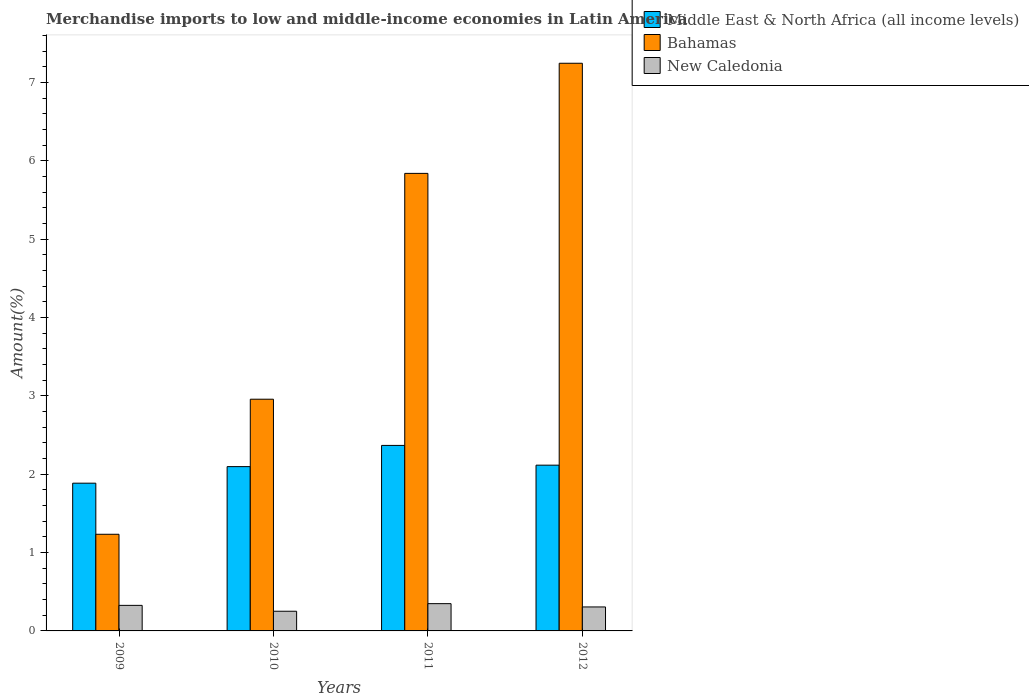How many different coloured bars are there?
Offer a very short reply. 3. Are the number of bars on each tick of the X-axis equal?
Your answer should be very brief. Yes. How many bars are there on the 3rd tick from the right?
Ensure brevity in your answer.  3. What is the percentage of amount earned from merchandise imports in Bahamas in 2012?
Keep it short and to the point. 7.25. Across all years, what is the maximum percentage of amount earned from merchandise imports in New Caledonia?
Offer a terse response. 0.35. Across all years, what is the minimum percentage of amount earned from merchandise imports in New Caledonia?
Your response must be concise. 0.25. What is the total percentage of amount earned from merchandise imports in Bahamas in the graph?
Your response must be concise. 17.28. What is the difference between the percentage of amount earned from merchandise imports in New Caledonia in 2011 and that in 2012?
Keep it short and to the point. 0.04. What is the difference between the percentage of amount earned from merchandise imports in Bahamas in 2011 and the percentage of amount earned from merchandise imports in New Caledonia in 2010?
Your response must be concise. 5.59. What is the average percentage of amount earned from merchandise imports in New Caledonia per year?
Give a very brief answer. 0.31. In the year 2012, what is the difference between the percentage of amount earned from merchandise imports in Bahamas and percentage of amount earned from merchandise imports in New Caledonia?
Offer a very short reply. 6.94. In how many years, is the percentage of amount earned from merchandise imports in Middle East & North Africa (all income levels) greater than 0.6000000000000001 %?
Provide a succinct answer. 4. What is the ratio of the percentage of amount earned from merchandise imports in New Caledonia in 2009 to that in 2012?
Offer a very short reply. 1.07. Is the difference between the percentage of amount earned from merchandise imports in Bahamas in 2009 and 2011 greater than the difference between the percentage of amount earned from merchandise imports in New Caledonia in 2009 and 2011?
Your response must be concise. No. What is the difference between the highest and the second highest percentage of amount earned from merchandise imports in New Caledonia?
Give a very brief answer. 0.02. What is the difference between the highest and the lowest percentage of amount earned from merchandise imports in New Caledonia?
Provide a short and direct response. 0.1. In how many years, is the percentage of amount earned from merchandise imports in Middle East & North Africa (all income levels) greater than the average percentage of amount earned from merchandise imports in Middle East & North Africa (all income levels) taken over all years?
Make the answer very short. 1. Is the sum of the percentage of amount earned from merchandise imports in New Caledonia in 2011 and 2012 greater than the maximum percentage of amount earned from merchandise imports in Bahamas across all years?
Give a very brief answer. No. What does the 1st bar from the left in 2012 represents?
Provide a succinct answer. Middle East & North Africa (all income levels). What does the 1st bar from the right in 2011 represents?
Your answer should be compact. New Caledonia. Is it the case that in every year, the sum of the percentage of amount earned from merchandise imports in Middle East & North Africa (all income levels) and percentage of amount earned from merchandise imports in New Caledonia is greater than the percentage of amount earned from merchandise imports in Bahamas?
Provide a succinct answer. No. Are all the bars in the graph horizontal?
Provide a succinct answer. No. Are the values on the major ticks of Y-axis written in scientific E-notation?
Provide a succinct answer. No. Does the graph contain any zero values?
Offer a terse response. No. Does the graph contain grids?
Ensure brevity in your answer.  No. Where does the legend appear in the graph?
Offer a very short reply. Top right. What is the title of the graph?
Provide a short and direct response. Merchandise imports to low and middle-income economies in Latin America. What is the label or title of the Y-axis?
Ensure brevity in your answer.  Amount(%). What is the Amount(%) in Middle East & North Africa (all income levels) in 2009?
Provide a short and direct response. 1.89. What is the Amount(%) of Bahamas in 2009?
Keep it short and to the point. 1.23. What is the Amount(%) of New Caledonia in 2009?
Offer a very short reply. 0.33. What is the Amount(%) of Middle East & North Africa (all income levels) in 2010?
Offer a terse response. 2.1. What is the Amount(%) of Bahamas in 2010?
Your answer should be very brief. 2.96. What is the Amount(%) in New Caledonia in 2010?
Offer a terse response. 0.25. What is the Amount(%) in Middle East & North Africa (all income levels) in 2011?
Offer a terse response. 2.37. What is the Amount(%) in Bahamas in 2011?
Offer a terse response. 5.84. What is the Amount(%) of New Caledonia in 2011?
Offer a very short reply. 0.35. What is the Amount(%) of Middle East & North Africa (all income levels) in 2012?
Offer a terse response. 2.12. What is the Amount(%) in Bahamas in 2012?
Make the answer very short. 7.25. What is the Amount(%) in New Caledonia in 2012?
Give a very brief answer. 0.31. Across all years, what is the maximum Amount(%) in Middle East & North Africa (all income levels)?
Your response must be concise. 2.37. Across all years, what is the maximum Amount(%) of Bahamas?
Ensure brevity in your answer.  7.25. Across all years, what is the maximum Amount(%) in New Caledonia?
Provide a short and direct response. 0.35. Across all years, what is the minimum Amount(%) in Middle East & North Africa (all income levels)?
Ensure brevity in your answer.  1.89. Across all years, what is the minimum Amount(%) in Bahamas?
Offer a terse response. 1.23. Across all years, what is the minimum Amount(%) of New Caledonia?
Give a very brief answer. 0.25. What is the total Amount(%) of Middle East & North Africa (all income levels) in the graph?
Your answer should be very brief. 8.47. What is the total Amount(%) of Bahamas in the graph?
Ensure brevity in your answer.  17.28. What is the total Amount(%) of New Caledonia in the graph?
Keep it short and to the point. 1.23. What is the difference between the Amount(%) in Middle East & North Africa (all income levels) in 2009 and that in 2010?
Offer a terse response. -0.21. What is the difference between the Amount(%) of Bahamas in 2009 and that in 2010?
Provide a succinct answer. -1.72. What is the difference between the Amount(%) in New Caledonia in 2009 and that in 2010?
Provide a succinct answer. 0.08. What is the difference between the Amount(%) of Middle East & North Africa (all income levels) in 2009 and that in 2011?
Your answer should be very brief. -0.48. What is the difference between the Amount(%) of Bahamas in 2009 and that in 2011?
Ensure brevity in your answer.  -4.61. What is the difference between the Amount(%) in New Caledonia in 2009 and that in 2011?
Your answer should be compact. -0.02. What is the difference between the Amount(%) of Middle East & North Africa (all income levels) in 2009 and that in 2012?
Your answer should be compact. -0.23. What is the difference between the Amount(%) of Bahamas in 2009 and that in 2012?
Your response must be concise. -6.01. What is the difference between the Amount(%) in New Caledonia in 2009 and that in 2012?
Provide a short and direct response. 0.02. What is the difference between the Amount(%) in Middle East & North Africa (all income levels) in 2010 and that in 2011?
Your answer should be very brief. -0.27. What is the difference between the Amount(%) of Bahamas in 2010 and that in 2011?
Offer a very short reply. -2.88. What is the difference between the Amount(%) in New Caledonia in 2010 and that in 2011?
Offer a very short reply. -0.1. What is the difference between the Amount(%) of Middle East & North Africa (all income levels) in 2010 and that in 2012?
Keep it short and to the point. -0.02. What is the difference between the Amount(%) in Bahamas in 2010 and that in 2012?
Ensure brevity in your answer.  -4.29. What is the difference between the Amount(%) in New Caledonia in 2010 and that in 2012?
Your response must be concise. -0.05. What is the difference between the Amount(%) in Middle East & North Africa (all income levels) in 2011 and that in 2012?
Provide a short and direct response. 0.25. What is the difference between the Amount(%) of Bahamas in 2011 and that in 2012?
Your response must be concise. -1.41. What is the difference between the Amount(%) of New Caledonia in 2011 and that in 2012?
Offer a very short reply. 0.04. What is the difference between the Amount(%) in Middle East & North Africa (all income levels) in 2009 and the Amount(%) in Bahamas in 2010?
Provide a succinct answer. -1.07. What is the difference between the Amount(%) of Middle East & North Africa (all income levels) in 2009 and the Amount(%) of New Caledonia in 2010?
Offer a very short reply. 1.63. What is the difference between the Amount(%) in Bahamas in 2009 and the Amount(%) in New Caledonia in 2010?
Your response must be concise. 0.98. What is the difference between the Amount(%) in Middle East & North Africa (all income levels) in 2009 and the Amount(%) in Bahamas in 2011?
Keep it short and to the point. -3.95. What is the difference between the Amount(%) in Middle East & North Africa (all income levels) in 2009 and the Amount(%) in New Caledonia in 2011?
Give a very brief answer. 1.54. What is the difference between the Amount(%) of Bahamas in 2009 and the Amount(%) of New Caledonia in 2011?
Give a very brief answer. 0.89. What is the difference between the Amount(%) of Middle East & North Africa (all income levels) in 2009 and the Amount(%) of Bahamas in 2012?
Provide a succinct answer. -5.36. What is the difference between the Amount(%) of Middle East & North Africa (all income levels) in 2009 and the Amount(%) of New Caledonia in 2012?
Provide a short and direct response. 1.58. What is the difference between the Amount(%) of Bahamas in 2009 and the Amount(%) of New Caledonia in 2012?
Offer a terse response. 0.93. What is the difference between the Amount(%) in Middle East & North Africa (all income levels) in 2010 and the Amount(%) in Bahamas in 2011?
Make the answer very short. -3.74. What is the difference between the Amount(%) in Middle East & North Africa (all income levels) in 2010 and the Amount(%) in New Caledonia in 2011?
Keep it short and to the point. 1.75. What is the difference between the Amount(%) in Bahamas in 2010 and the Amount(%) in New Caledonia in 2011?
Offer a terse response. 2.61. What is the difference between the Amount(%) in Middle East & North Africa (all income levels) in 2010 and the Amount(%) in Bahamas in 2012?
Offer a terse response. -5.15. What is the difference between the Amount(%) of Middle East & North Africa (all income levels) in 2010 and the Amount(%) of New Caledonia in 2012?
Your answer should be compact. 1.79. What is the difference between the Amount(%) in Bahamas in 2010 and the Amount(%) in New Caledonia in 2012?
Your response must be concise. 2.65. What is the difference between the Amount(%) in Middle East & North Africa (all income levels) in 2011 and the Amount(%) in Bahamas in 2012?
Provide a short and direct response. -4.88. What is the difference between the Amount(%) of Middle East & North Africa (all income levels) in 2011 and the Amount(%) of New Caledonia in 2012?
Offer a very short reply. 2.06. What is the difference between the Amount(%) of Bahamas in 2011 and the Amount(%) of New Caledonia in 2012?
Offer a terse response. 5.53. What is the average Amount(%) of Middle East & North Africa (all income levels) per year?
Provide a succinct answer. 2.12. What is the average Amount(%) of Bahamas per year?
Your response must be concise. 4.32. What is the average Amount(%) in New Caledonia per year?
Give a very brief answer. 0.31. In the year 2009, what is the difference between the Amount(%) in Middle East & North Africa (all income levels) and Amount(%) in Bahamas?
Your response must be concise. 0.65. In the year 2009, what is the difference between the Amount(%) of Middle East & North Africa (all income levels) and Amount(%) of New Caledonia?
Your answer should be compact. 1.56. In the year 2009, what is the difference between the Amount(%) of Bahamas and Amount(%) of New Caledonia?
Provide a short and direct response. 0.91. In the year 2010, what is the difference between the Amount(%) in Middle East & North Africa (all income levels) and Amount(%) in Bahamas?
Your response must be concise. -0.86. In the year 2010, what is the difference between the Amount(%) in Middle East & North Africa (all income levels) and Amount(%) in New Caledonia?
Keep it short and to the point. 1.85. In the year 2010, what is the difference between the Amount(%) in Bahamas and Amount(%) in New Caledonia?
Offer a terse response. 2.71. In the year 2011, what is the difference between the Amount(%) in Middle East & North Africa (all income levels) and Amount(%) in Bahamas?
Keep it short and to the point. -3.47. In the year 2011, what is the difference between the Amount(%) of Middle East & North Africa (all income levels) and Amount(%) of New Caledonia?
Ensure brevity in your answer.  2.02. In the year 2011, what is the difference between the Amount(%) of Bahamas and Amount(%) of New Caledonia?
Keep it short and to the point. 5.49. In the year 2012, what is the difference between the Amount(%) in Middle East & North Africa (all income levels) and Amount(%) in Bahamas?
Make the answer very short. -5.13. In the year 2012, what is the difference between the Amount(%) of Middle East & North Africa (all income levels) and Amount(%) of New Caledonia?
Offer a terse response. 1.81. In the year 2012, what is the difference between the Amount(%) in Bahamas and Amount(%) in New Caledonia?
Provide a short and direct response. 6.94. What is the ratio of the Amount(%) in Middle East & North Africa (all income levels) in 2009 to that in 2010?
Provide a succinct answer. 0.9. What is the ratio of the Amount(%) of Bahamas in 2009 to that in 2010?
Your response must be concise. 0.42. What is the ratio of the Amount(%) of New Caledonia in 2009 to that in 2010?
Make the answer very short. 1.3. What is the ratio of the Amount(%) of Middle East & North Africa (all income levels) in 2009 to that in 2011?
Your response must be concise. 0.8. What is the ratio of the Amount(%) in Bahamas in 2009 to that in 2011?
Offer a terse response. 0.21. What is the ratio of the Amount(%) of New Caledonia in 2009 to that in 2011?
Offer a terse response. 0.94. What is the ratio of the Amount(%) in Middle East & North Africa (all income levels) in 2009 to that in 2012?
Offer a very short reply. 0.89. What is the ratio of the Amount(%) in Bahamas in 2009 to that in 2012?
Offer a very short reply. 0.17. What is the ratio of the Amount(%) of New Caledonia in 2009 to that in 2012?
Your answer should be compact. 1.07. What is the ratio of the Amount(%) in Middle East & North Africa (all income levels) in 2010 to that in 2011?
Give a very brief answer. 0.89. What is the ratio of the Amount(%) of Bahamas in 2010 to that in 2011?
Offer a terse response. 0.51. What is the ratio of the Amount(%) in New Caledonia in 2010 to that in 2011?
Your answer should be compact. 0.72. What is the ratio of the Amount(%) of Middle East & North Africa (all income levels) in 2010 to that in 2012?
Keep it short and to the point. 0.99. What is the ratio of the Amount(%) in Bahamas in 2010 to that in 2012?
Your answer should be very brief. 0.41. What is the ratio of the Amount(%) in New Caledonia in 2010 to that in 2012?
Ensure brevity in your answer.  0.82. What is the ratio of the Amount(%) of Middle East & North Africa (all income levels) in 2011 to that in 2012?
Provide a succinct answer. 1.12. What is the ratio of the Amount(%) in Bahamas in 2011 to that in 2012?
Your answer should be compact. 0.81. What is the ratio of the Amount(%) of New Caledonia in 2011 to that in 2012?
Offer a very short reply. 1.14. What is the difference between the highest and the second highest Amount(%) in Middle East & North Africa (all income levels)?
Keep it short and to the point. 0.25. What is the difference between the highest and the second highest Amount(%) in Bahamas?
Make the answer very short. 1.41. What is the difference between the highest and the second highest Amount(%) in New Caledonia?
Ensure brevity in your answer.  0.02. What is the difference between the highest and the lowest Amount(%) of Middle East & North Africa (all income levels)?
Offer a terse response. 0.48. What is the difference between the highest and the lowest Amount(%) of Bahamas?
Your answer should be very brief. 6.01. What is the difference between the highest and the lowest Amount(%) of New Caledonia?
Provide a succinct answer. 0.1. 